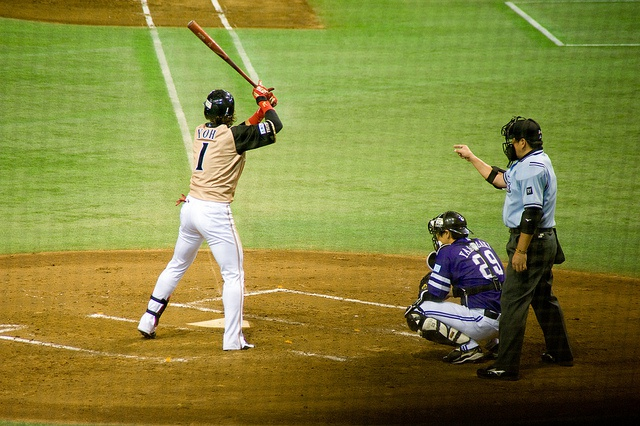Describe the objects in this image and their specific colors. I can see people in olive, black, darkgray, and lightblue tones, people in olive, white, black, tan, and darkgray tones, people in olive, black, navy, lightgray, and darkgray tones, baseball bat in olive, maroon, black, and brown tones, and baseball glove in olive and black tones in this image. 